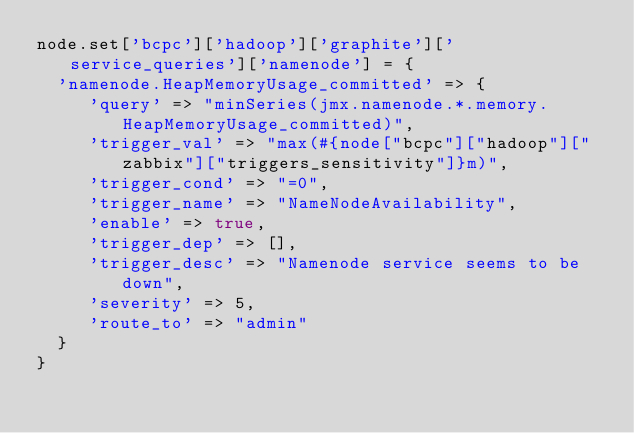<code> <loc_0><loc_0><loc_500><loc_500><_Ruby_>node.set['bcpc']['hadoop']['graphite']['service_queries']['namenode'] = {
  'namenode.HeapMemoryUsage_committed' => {
     'query' => "minSeries(jmx.namenode.*.memory.HeapMemoryUsage_committed)",
     'trigger_val' => "max(#{node["bcpc"]["hadoop"]["zabbix"]["triggers_sensitivity"]}m)",
     'trigger_cond' => "=0",
     'trigger_name' => "NameNodeAvailability",
     'enable' => true,
     'trigger_dep' => [],
     'trigger_desc' => "Namenode service seems to be down",
     'severity' => 5,
     'route_to' => "admin"
  }
}
</code> 